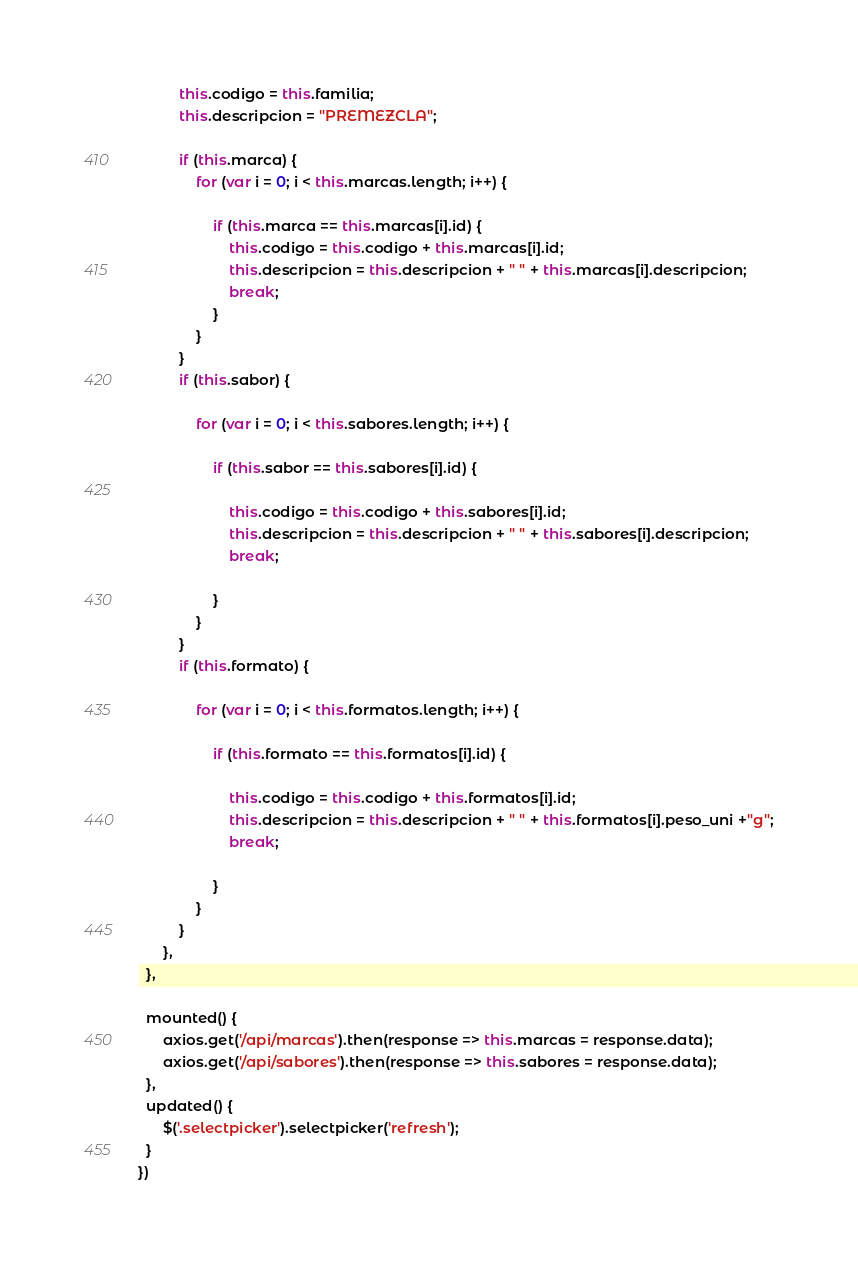<code> <loc_0><loc_0><loc_500><loc_500><_JavaScript_>
          this.codigo = this.familia;
          this.descripcion = "PREMEZCLA";

          if (this.marca) {
              for (var i = 0; i < this.marcas.length; i++) {

                  if (this.marca == this.marcas[i].id) {
                      this.codigo = this.codigo + this.marcas[i].id;
                      this.descripcion = this.descripcion + " " + this.marcas[i].descripcion;
                      break;
                  }
              }
          }
          if (this.sabor) {

              for (var i = 0; i < this.sabores.length; i++) {

                  if (this.sabor == this.sabores[i].id) {

                      this.codigo = this.codigo + this.sabores[i].id;
                      this.descripcion = this.descripcion + " " + this.sabores[i].descripcion;
                      break;

                  }
              }
          }
          if (this.formato) {

              for (var i = 0; i < this.formatos.length; i++) {

                  if (this.formato == this.formatos[i].id) {

                      this.codigo = this.codigo + this.formatos[i].id;
                      this.descripcion = this.descripcion + " " + this.formatos[i].peso_uni +"g";
                      break;

                  }
              }
          }
	  },
  },

  mounted() {
	  axios.get('/api/marcas').then(response => this.marcas = response.data);
	  axios.get('/api/sabores').then(response => this.sabores = response.data);
  },
  updated() {
      $('.selectpicker').selectpicker('refresh');
  }
})
</code> 